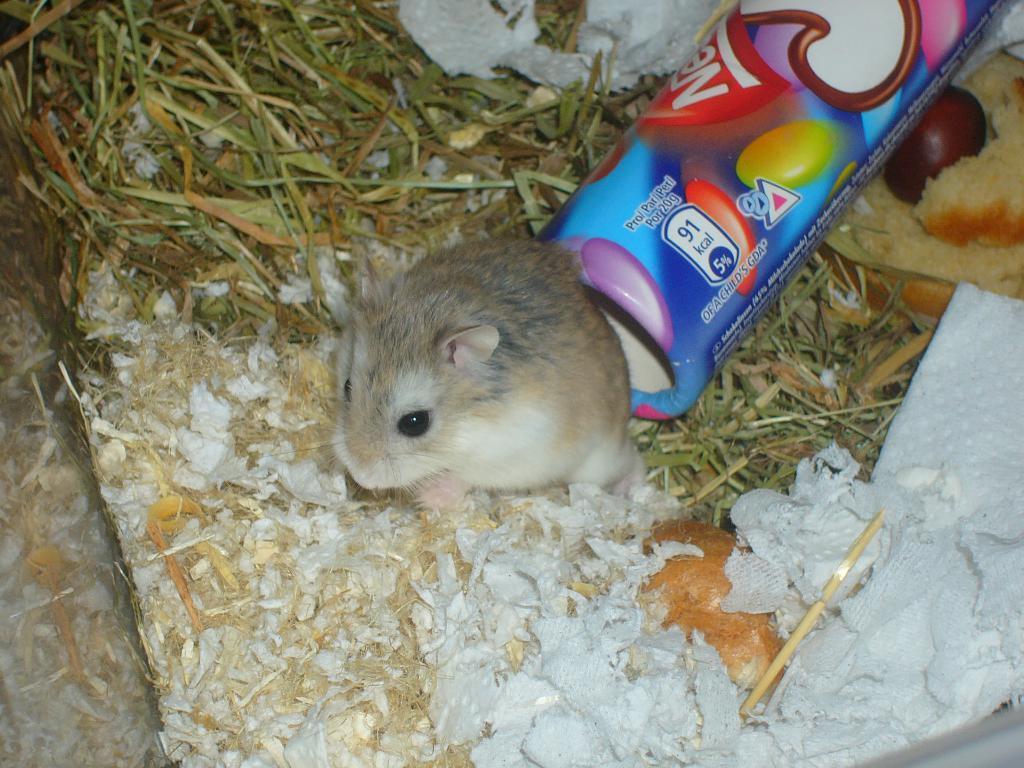Please provide a concise description of this image. There is a mice, tissue paper, grass and other items. 